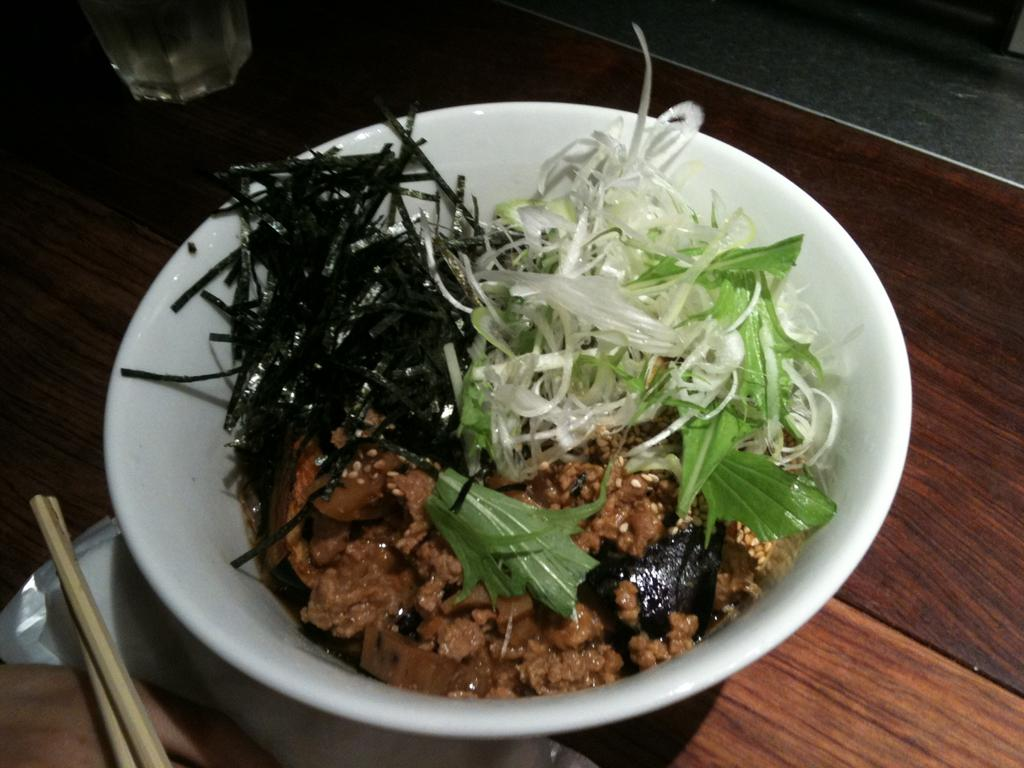What is in the bowl that is visible in the image? There is a bowl of food in the image. What utensil is located on the left side of the image? There is a chopstick on the left side of the image. How many servants are present in the image? There is no mention of servants in the image, as it only features a bowl of food and a chopstick. 